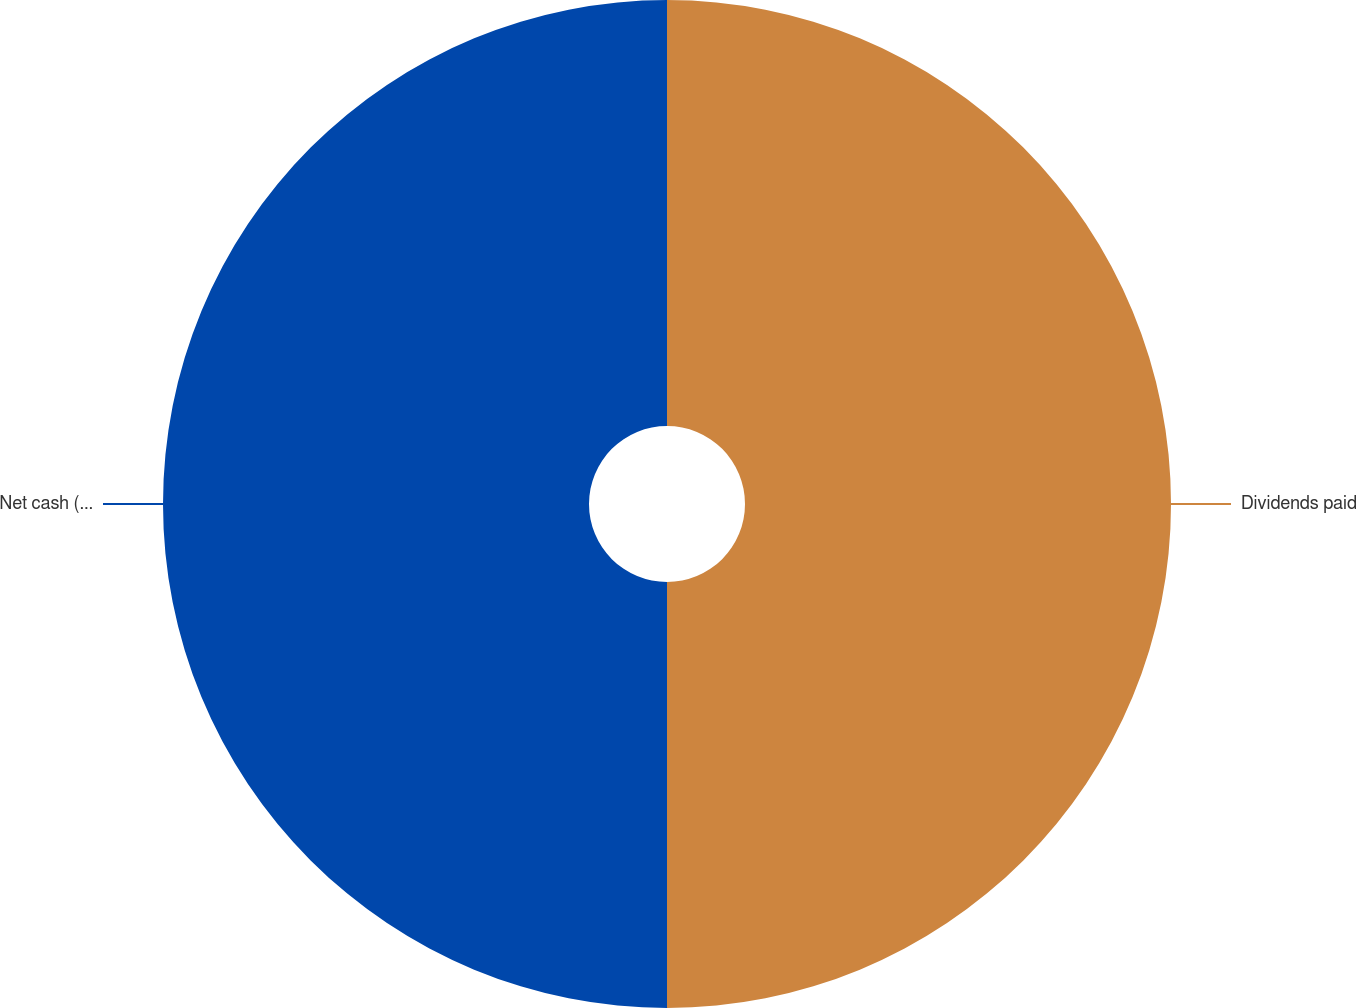<chart> <loc_0><loc_0><loc_500><loc_500><pie_chart><fcel>Dividends paid<fcel>Net cash (used by) provided by<nl><fcel>50.0%<fcel>50.0%<nl></chart> 